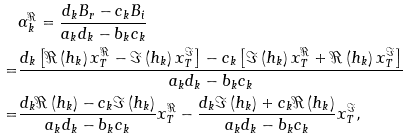Convert formula to latex. <formula><loc_0><loc_0><loc_500><loc_500>& \alpha _ { k } ^ { \Re } = \frac { { { d _ { k } } { B _ { r } } - { c _ { k } } { B _ { i } } } } { { { a _ { k } } { d _ { k } } - { b _ { k } } { c _ { k } } } } \\ = & \frac { { { d _ { k } } \left [ { \Re \left ( { { { h } _ { k } } } \right ) { x } _ { T } ^ { \Re } - \Im \left ( { { { h } _ { k } } } \right ) { x } _ { T } ^ { \Im } } \right ] - { c _ { k } } \left [ { \Im \left ( { { { h } _ { k } } } \right ) { x } _ { T } ^ { \Re } + \Re \left ( { { { h } _ { k } } } \right ) { x } _ { T } ^ { \Im } } \right ] } } { { { a _ { k } } { d _ { k } } - { b _ { k } } { c _ { k } } } } \\ = & \frac { { { d _ { k } } \Re \left ( { { { h } _ { k } } } \right ) - { c _ { k } } \Im \left ( { { { h } _ { k } } } \right ) } } { { { a _ { k } } { d _ { k } } - { b _ { k } } { c _ { k } } } } { x } _ { T } ^ { \Re } - \frac { { { d _ { k } } \Im \left ( { { { h } _ { k } } } \right ) + { c _ { k } } \Re \left ( { { { h } _ { k } } } \right ) } } { { { a _ { k } } { d _ { k } } - { b _ { k } } { c _ { k } } } } { x } _ { T } ^ { \Im } ,</formula> 